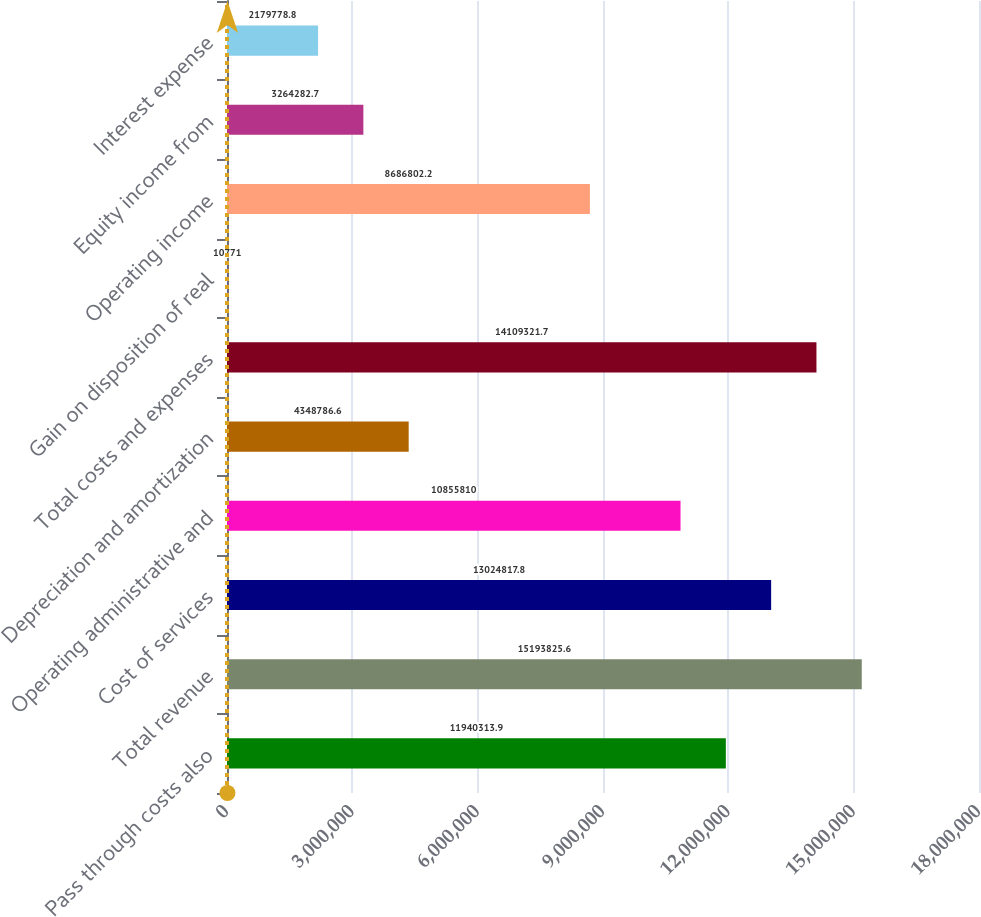Convert chart to OTSL. <chart><loc_0><loc_0><loc_500><loc_500><bar_chart><fcel>Pass through costs also<fcel>Total revenue<fcel>Cost of services<fcel>Operating administrative and<fcel>Depreciation and amortization<fcel>Total costs and expenses<fcel>Gain on disposition of real<fcel>Operating income<fcel>Equity income from<fcel>Interest expense<nl><fcel>1.19403e+07<fcel>1.51938e+07<fcel>1.30248e+07<fcel>1.08558e+07<fcel>4.34879e+06<fcel>1.41093e+07<fcel>10771<fcel>8.6868e+06<fcel>3.26428e+06<fcel>2.17978e+06<nl></chart> 